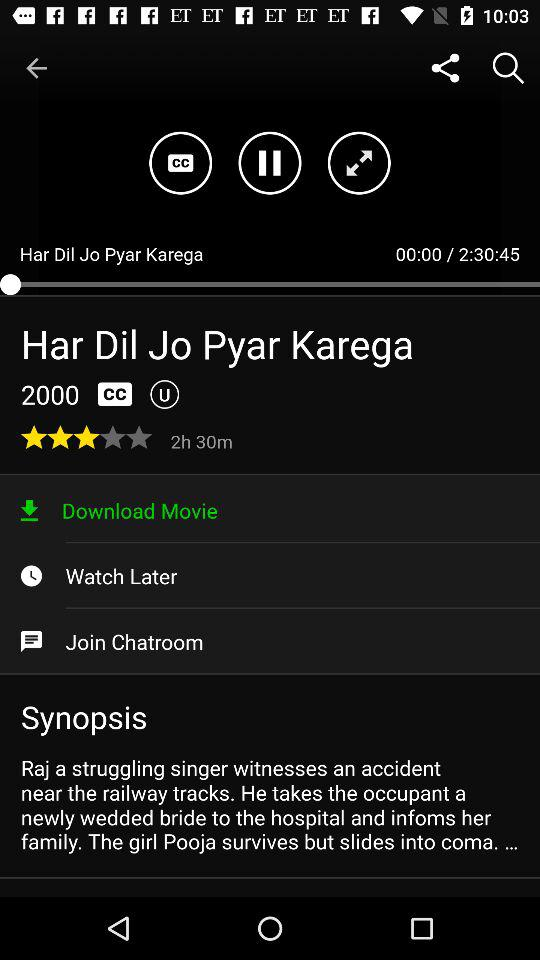What is the given rating? The rating is 3 stars. 